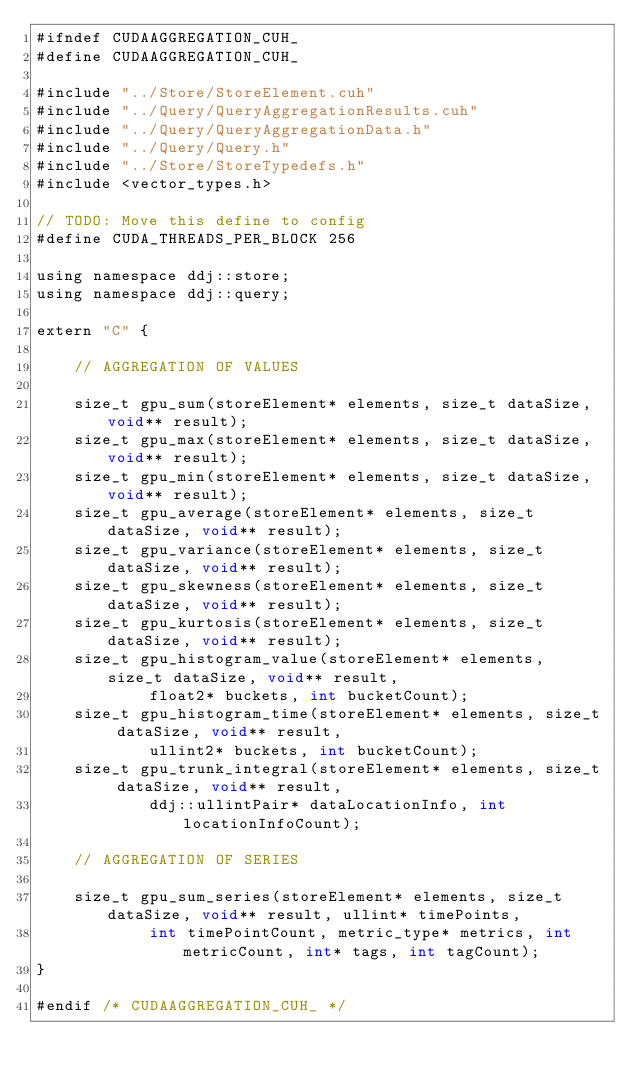<code> <loc_0><loc_0><loc_500><loc_500><_Cuda_>#ifndef CUDAAGGREGATION_CUH_
#define CUDAAGGREGATION_CUH_

#include "../Store/StoreElement.cuh"
#include "../Query/QueryAggregationResults.cuh"
#include "../Query/QueryAggregationData.h"
#include "../Query/Query.h"
#include "../Store/StoreTypedefs.h"
#include <vector_types.h>

// TODO: Move this define to config
#define CUDA_THREADS_PER_BLOCK 256

using namespace ddj::store;
using namespace ddj::query;

extern "C" {

	// AGGREGATION OF VALUES

	size_t gpu_sum(storeElement* elements, size_t dataSize, void** result);
	size_t gpu_max(storeElement* elements, size_t dataSize, void** result);
	size_t gpu_min(storeElement* elements, size_t dataSize, void** result);
	size_t gpu_average(storeElement* elements, size_t dataSize, void** result);
	size_t gpu_variance(storeElement* elements, size_t dataSize, void** result);
	size_t gpu_skewness(storeElement* elements, size_t dataSize, void** result);
	size_t gpu_kurtosis(storeElement* elements, size_t dataSize, void** result);
	size_t gpu_histogram_value(storeElement* elements, size_t dataSize, void** result,
			float2* buckets, int bucketCount);
	size_t gpu_histogram_time(storeElement* elements, size_t dataSize, void** result,
			ullint2* buckets, int bucketCount);
	size_t gpu_trunk_integral(storeElement* elements, size_t dataSize, void** result,
			ddj::ullintPair* dataLocationInfo, int locationInfoCount);

	// AGGREGATION OF SERIES

	size_t gpu_sum_series(storeElement* elements, size_t dataSize, void** result, ullint* timePoints,
			int timePointCount, metric_type* metrics, int metricCount, int* tags, int tagCount);
}

#endif /* CUDAAGGREGATION_CUH_ */
</code> 